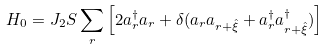Convert formula to latex. <formula><loc_0><loc_0><loc_500><loc_500>H _ { 0 } = J _ { 2 } S \sum _ { r } \left [ 2 a ^ { \dagger } _ { r } a _ { r } + \delta ( a _ { r } a _ { r + \hat { \xi } } + a ^ { \dagger } _ { r } a ^ { \dagger } _ { r + \hat { \xi } } ) \right ]</formula> 